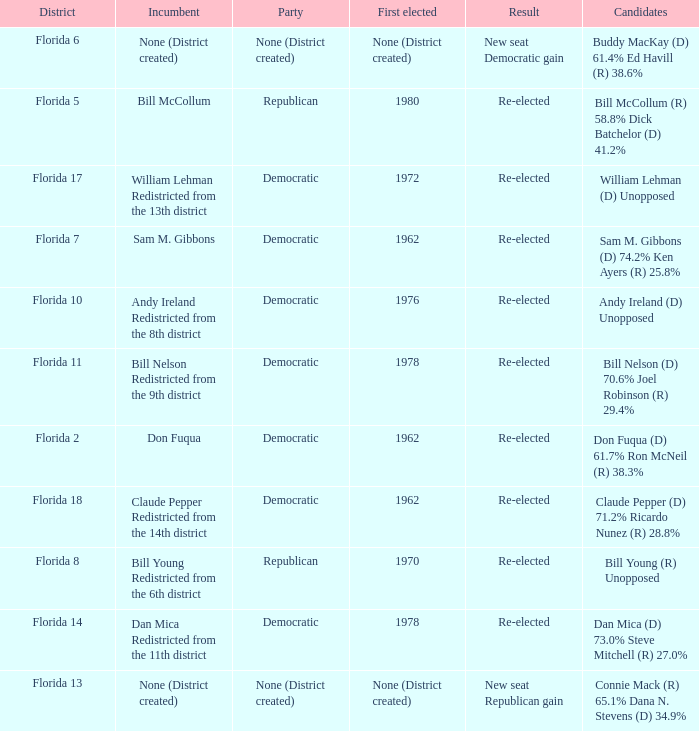 how many candidates with result being new seat democratic gain 1.0. 